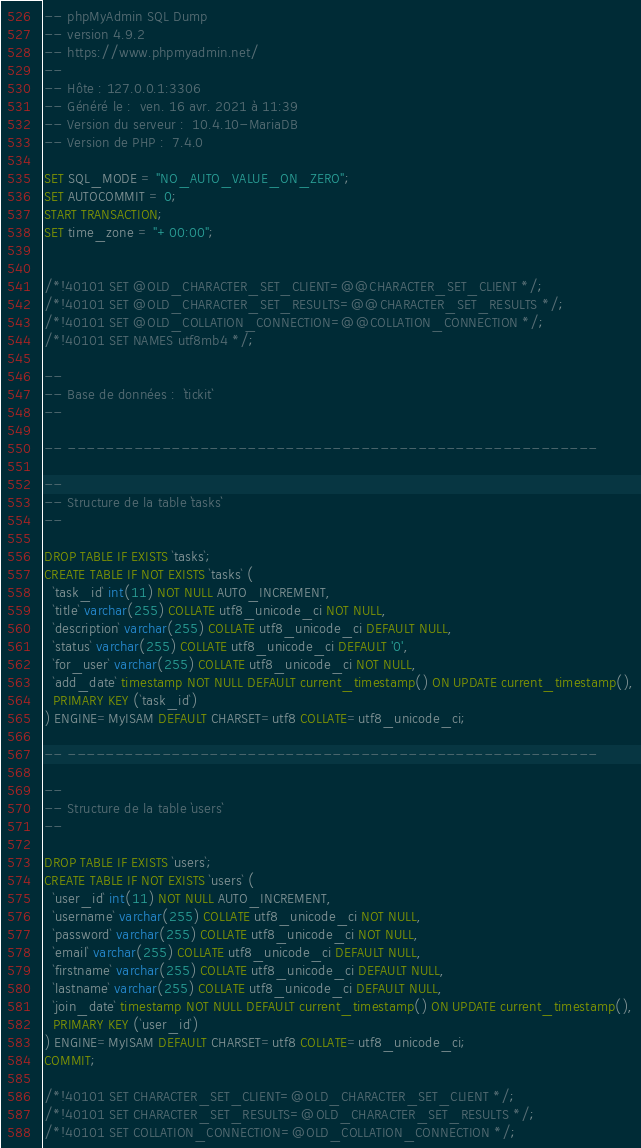<code> <loc_0><loc_0><loc_500><loc_500><_SQL_>-- phpMyAdmin SQL Dump
-- version 4.9.2
-- https://www.phpmyadmin.net/
--
-- Hôte : 127.0.0.1:3306
-- Généré le :  ven. 16 avr. 2021 à 11:39
-- Version du serveur :  10.4.10-MariaDB
-- Version de PHP :  7.4.0

SET SQL_MODE = "NO_AUTO_VALUE_ON_ZERO";
SET AUTOCOMMIT = 0;
START TRANSACTION;
SET time_zone = "+00:00";


/*!40101 SET @OLD_CHARACTER_SET_CLIENT=@@CHARACTER_SET_CLIENT */;
/*!40101 SET @OLD_CHARACTER_SET_RESULTS=@@CHARACTER_SET_RESULTS */;
/*!40101 SET @OLD_COLLATION_CONNECTION=@@COLLATION_CONNECTION */;
/*!40101 SET NAMES utf8mb4 */;

--
-- Base de données :  `tickit`
--

-- --------------------------------------------------------

--
-- Structure de la table `tasks`
--

DROP TABLE IF EXISTS `tasks`;
CREATE TABLE IF NOT EXISTS `tasks` (
  `task_id` int(11) NOT NULL AUTO_INCREMENT,
  `title` varchar(255) COLLATE utf8_unicode_ci NOT NULL,
  `description` varchar(255) COLLATE utf8_unicode_ci DEFAULT NULL,
  `status` varchar(255) COLLATE utf8_unicode_ci DEFAULT '0',
  `for_user` varchar(255) COLLATE utf8_unicode_ci NOT NULL,
  `add_date` timestamp NOT NULL DEFAULT current_timestamp() ON UPDATE current_timestamp(),
  PRIMARY KEY (`task_id`)
) ENGINE=MyISAM DEFAULT CHARSET=utf8 COLLATE=utf8_unicode_ci;

-- --------------------------------------------------------

--
-- Structure de la table `users`
--

DROP TABLE IF EXISTS `users`;
CREATE TABLE IF NOT EXISTS `users` (
  `user_id` int(11) NOT NULL AUTO_INCREMENT,
  `username` varchar(255) COLLATE utf8_unicode_ci NOT NULL,
  `password` varchar(255) COLLATE utf8_unicode_ci NOT NULL,
  `email` varchar(255) COLLATE utf8_unicode_ci DEFAULT NULL,
  `firstname` varchar(255) COLLATE utf8_unicode_ci DEFAULT NULL,
  `lastname` varchar(255) COLLATE utf8_unicode_ci DEFAULT NULL,
  `join_date` timestamp NOT NULL DEFAULT current_timestamp() ON UPDATE current_timestamp(),
  PRIMARY KEY (`user_id`)
) ENGINE=MyISAM DEFAULT CHARSET=utf8 COLLATE=utf8_unicode_ci;
COMMIT;

/*!40101 SET CHARACTER_SET_CLIENT=@OLD_CHARACTER_SET_CLIENT */;
/*!40101 SET CHARACTER_SET_RESULTS=@OLD_CHARACTER_SET_RESULTS */;
/*!40101 SET COLLATION_CONNECTION=@OLD_COLLATION_CONNECTION */;
</code> 